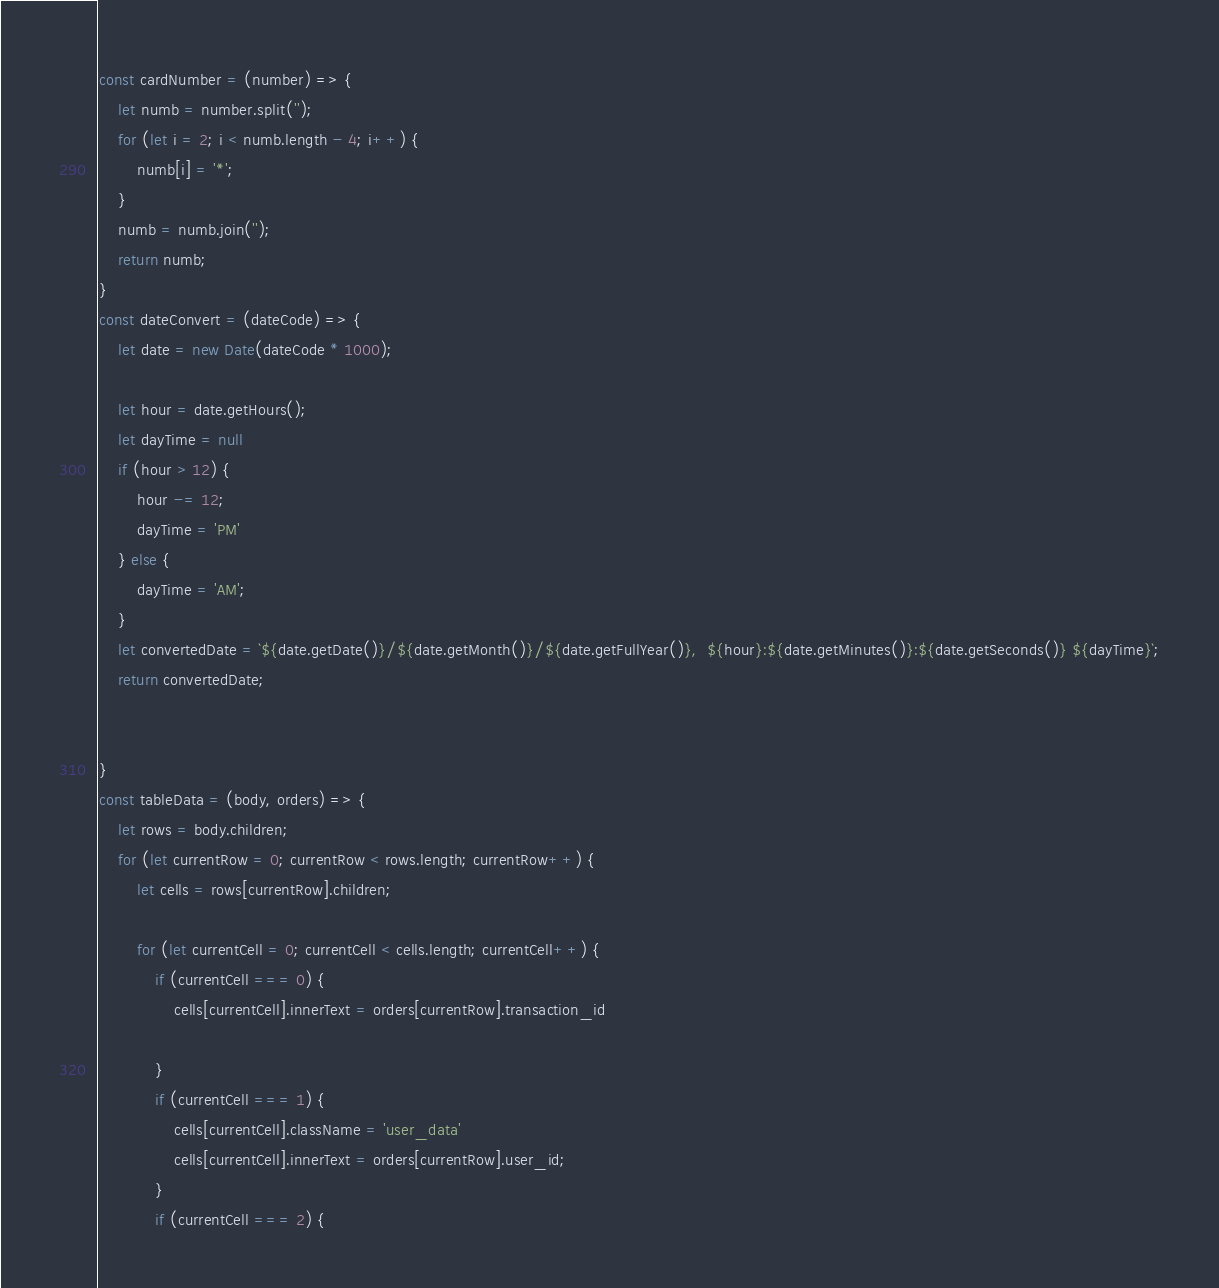<code> <loc_0><loc_0><loc_500><loc_500><_JavaScript_>const cardNumber = (number) => {
    let numb = number.split('');
    for (let i = 2; i < numb.length - 4; i++) {
        numb[i] = '*';
    }
    numb = numb.join('');
    return numb;
}
const dateConvert = (dateCode) => {
    let date = new Date(dateCode * 1000);

    let hour = date.getHours();
    let dayTime = null
    if (hour > 12) {
        hour -= 12;
        dayTime = 'PM'
    } else {
        dayTime = 'AM';
    }
    let convertedDate = `${date.getDate()}/${date.getMonth()}/${date.getFullYear()},  ${hour}:${date.getMinutes()}:${date.getSeconds()} ${dayTime}`;
    return convertedDate;


}
const tableData = (body, orders) => {
    let rows = body.children;
    for (let currentRow = 0; currentRow < rows.length; currentRow++) {
        let cells = rows[currentRow].children;

        for (let currentCell = 0; currentCell < cells.length; currentCell++) {
            if (currentCell === 0) {
                cells[currentCell].innerText = orders[currentRow].transaction_id

            }
            if (currentCell === 1) {
                cells[currentCell].className = 'user_data'
                cells[currentCell].innerText = orders[currentRow].user_id;
            }
            if (currentCell === 2) {</code> 